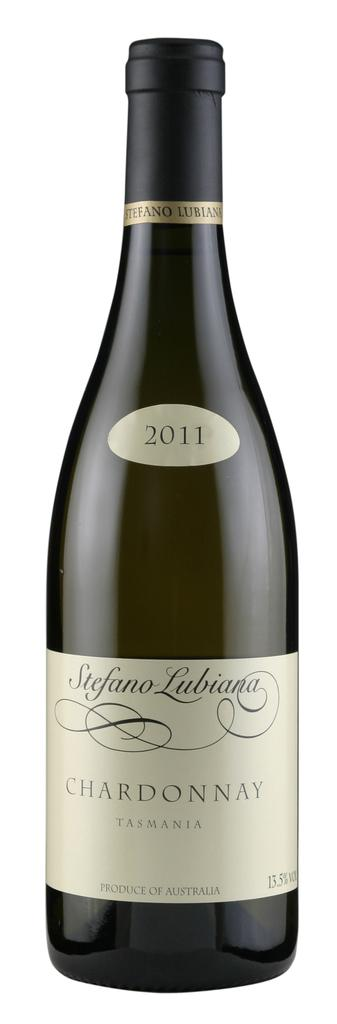<image>
Render a clear and concise summary of the photo. A Stefano Lubiana wine bottle placed against white background. 